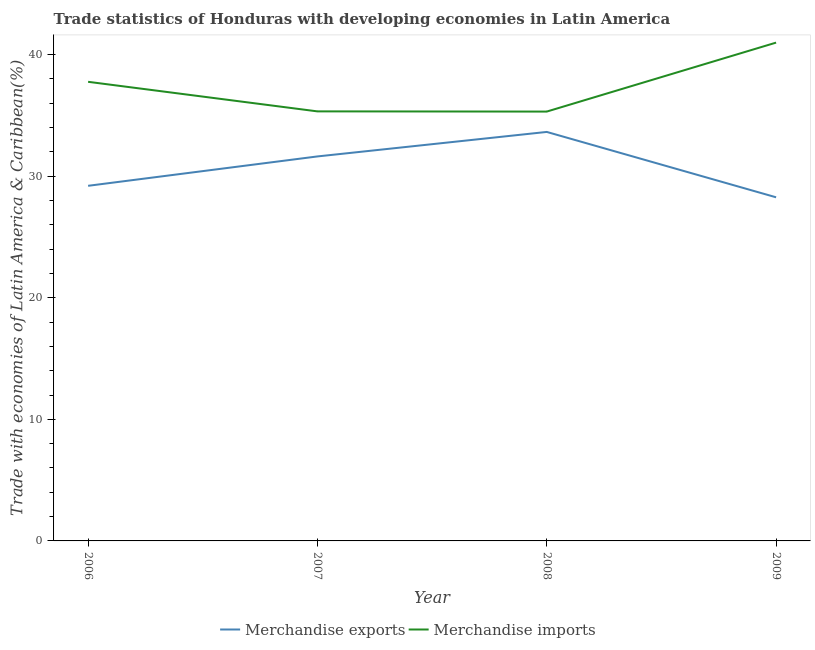What is the merchandise imports in 2009?
Your answer should be very brief. 40.98. Across all years, what is the maximum merchandise exports?
Your answer should be very brief. 33.63. Across all years, what is the minimum merchandise imports?
Give a very brief answer. 35.31. What is the total merchandise imports in the graph?
Provide a succinct answer. 149.37. What is the difference between the merchandise imports in 2006 and that in 2007?
Give a very brief answer. 2.43. What is the difference between the merchandise imports in 2007 and the merchandise exports in 2006?
Your answer should be compact. 6.12. What is the average merchandise exports per year?
Make the answer very short. 30.68. In the year 2007, what is the difference between the merchandise imports and merchandise exports?
Ensure brevity in your answer.  3.7. What is the ratio of the merchandise exports in 2006 to that in 2007?
Your response must be concise. 0.92. Is the difference between the merchandise exports in 2006 and 2009 greater than the difference between the merchandise imports in 2006 and 2009?
Your response must be concise. Yes. What is the difference between the highest and the second highest merchandise exports?
Offer a very short reply. 2.01. What is the difference between the highest and the lowest merchandise exports?
Offer a very short reply. 5.38. In how many years, is the merchandise imports greater than the average merchandise imports taken over all years?
Offer a terse response. 2. How many lines are there?
Provide a short and direct response. 2. How many years are there in the graph?
Keep it short and to the point. 4. What is the difference between two consecutive major ticks on the Y-axis?
Give a very brief answer. 10. Where does the legend appear in the graph?
Provide a succinct answer. Bottom center. How are the legend labels stacked?
Provide a short and direct response. Horizontal. What is the title of the graph?
Keep it short and to the point. Trade statistics of Honduras with developing economies in Latin America. Does "Diarrhea" appear as one of the legend labels in the graph?
Offer a very short reply. No. What is the label or title of the X-axis?
Make the answer very short. Year. What is the label or title of the Y-axis?
Keep it short and to the point. Trade with economies of Latin America & Caribbean(%). What is the Trade with economies of Latin America & Caribbean(%) in Merchandise exports in 2006?
Your response must be concise. 29.2. What is the Trade with economies of Latin America & Caribbean(%) in Merchandise imports in 2006?
Provide a succinct answer. 37.76. What is the Trade with economies of Latin America & Caribbean(%) of Merchandise exports in 2007?
Make the answer very short. 31.62. What is the Trade with economies of Latin America & Caribbean(%) of Merchandise imports in 2007?
Make the answer very short. 35.32. What is the Trade with economies of Latin America & Caribbean(%) of Merchandise exports in 2008?
Your answer should be compact. 33.63. What is the Trade with economies of Latin America & Caribbean(%) in Merchandise imports in 2008?
Your answer should be compact. 35.31. What is the Trade with economies of Latin America & Caribbean(%) of Merchandise exports in 2009?
Your answer should be very brief. 28.26. What is the Trade with economies of Latin America & Caribbean(%) of Merchandise imports in 2009?
Your answer should be compact. 40.98. Across all years, what is the maximum Trade with economies of Latin America & Caribbean(%) of Merchandise exports?
Provide a short and direct response. 33.63. Across all years, what is the maximum Trade with economies of Latin America & Caribbean(%) of Merchandise imports?
Make the answer very short. 40.98. Across all years, what is the minimum Trade with economies of Latin America & Caribbean(%) in Merchandise exports?
Make the answer very short. 28.26. Across all years, what is the minimum Trade with economies of Latin America & Caribbean(%) in Merchandise imports?
Give a very brief answer. 35.31. What is the total Trade with economies of Latin America & Caribbean(%) of Merchandise exports in the graph?
Your answer should be very brief. 122.71. What is the total Trade with economies of Latin America & Caribbean(%) of Merchandise imports in the graph?
Offer a very short reply. 149.37. What is the difference between the Trade with economies of Latin America & Caribbean(%) in Merchandise exports in 2006 and that in 2007?
Your answer should be very brief. -2.42. What is the difference between the Trade with economies of Latin America & Caribbean(%) in Merchandise imports in 2006 and that in 2007?
Keep it short and to the point. 2.43. What is the difference between the Trade with economies of Latin America & Caribbean(%) of Merchandise exports in 2006 and that in 2008?
Offer a terse response. -4.43. What is the difference between the Trade with economies of Latin America & Caribbean(%) in Merchandise imports in 2006 and that in 2008?
Offer a very short reply. 2.45. What is the difference between the Trade with economies of Latin America & Caribbean(%) in Merchandise exports in 2006 and that in 2009?
Provide a short and direct response. 0.95. What is the difference between the Trade with economies of Latin America & Caribbean(%) of Merchandise imports in 2006 and that in 2009?
Your answer should be compact. -3.22. What is the difference between the Trade with economies of Latin America & Caribbean(%) of Merchandise exports in 2007 and that in 2008?
Make the answer very short. -2.01. What is the difference between the Trade with economies of Latin America & Caribbean(%) of Merchandise imports in 2007 and that in 2008?
Make the answer very short. 0.02. What is the difference between the Trade with economies of Latin America & Caribbean(%) in Merchandise exports in 2007 and that in 2009?
Offer a very short reply. 3.36. What is the difference between the Trade with economies of Latin America & Caribbean(%) of Merchandise imports in 2007 and that in 2009?
Your response must be concise. -5.66. What is the difference between the Trade with economies of Latin America & Caribbean(%) in Merchandise exports in 2008 and that in 2009?
Provide a short and direct response. 5.38. What is the difference between the Trade with economies of Latin America & Caribbean(%) in Merchandise imports in 2008 and that in 2009?
Your answer should be compact. -5.67. What is the difference between the Trade with economies of Latin America & Caribbean(%) in Merchandise exports in 2006 and the Trade with economies of Latin America & Caribbean(%) in Merchandise imports in 2007?
Your answer should be compact. -6.12. What is the difference between the Trade with economies of Latin America & Caribbean(%) in Merchandise exports in 2006 and the Trade with economies of Latin America & Caribbean(%) in Merchandise imports in 2008?
Offer a very short reply. -6.11. What is the difference between the Trade with economies of Latin America & Caribbean(%) in Merchandise exports in 2006 and the Trade with economies of Latin America & Caribbean(%) in Merchandise imports in 2009?
Provide a succinct answer. -11.78. What is the difference between the Trade with economies of Latin America & Caribbean(%) of Merchandise exports in 2007 and the Trade with economies of Latin America & Caribbean(%) of Merchandise imports in 2008?
Your answer should be compact. -3.69. What is the difference between the Trade with economies of Latin America & Caribbean(%) in Merchandise exports in 2007 and the Trade with economies of Latin America & Caribbean(%) in Merchandise imports in 2009?
Offer a very short reply. -9.36. What is the difference between the Trade with economies of Latin America & Caribbean(%) of Merchandise exports in 2008 and the Trade with economies of Latin America & Caribbean(%) of Merchandise imports in 2009?
Your answer should be very brief. -7.35. What is the average Trade with economies of Latin America & Caribbean(%) in Merchandise exports per year?
Offer a very short reply. 30.68. What is the average Trade with economies of Latin America & Caribbean(%) in Merchandise imports per year?
Your answer should be very brief. 37.34. In the year 2006, what is the difference between the Trade with economies of Latin America & Caribbean(%) of Merchandise exports and Trade with economies of Latin America & Caribbean(%) of Merchandise imports?
Ensure brevity in your answer.  -8.55. In the year 2007, what is the difference between the Trade with economies of Latin America & Caribbean(%) of Merchandise exports and Trade with economies of Latin America & Caribbean(%) of Merchandise imports?
Make the answer very short. -3.7. In the year 2008, what is the difference between the Trade with economies of Latin America & Caribbean(%) of Merchandise exports and Trade with economies of Latin America & Caribbean(%) of Merchandise imports?
Make the answer very short. -1.67. In the year 2009, what is the difference between the Trade with economies of Latin America & Caribbean(%) of Merchandise exports and Trade with economies of Latin America & Caribbean(%) of Merchandise imports?
Make the answer very short. -12.72. What is the ratio of the Trade with economies of Latin America & Caribbean(%) in Merchandise exports in 2006 to that in 2007?
Give a very brief answer. 0.92. What is the ratio of the Trade with economies of Latin America & Caribbean(%) in Merchandise imports in 2006 to that in 2007?
Keep it short and to the point. 1.07. What is the ratio of the Trade with economies of Latin America & Caribbean(%) in Merchandise exports in 2006 to that in 2008?
Keep it short and to the point. 0.87. What is the ratio of the Trade with economies of Latin America & Caribbean(%) of Merchandise imports in 2006 to that in 2008?
Offer a terse response. 1.07. What is the ratio of the Trade with economies of Latin America & Caribbean(%) in Merchandise exports in 2006 to that in 2009?
Make the answer very short. 1.03. What is the ratio of the Trade with economies of Latin America & Caribbean(%) in Merchandise imports in 2006 to that in 2009?
Offer a very short reply. 0.92. What is the ratio of the Trade with economies of Latin America & Caribbean(%) in Merchandise exports in 2007 to that in 2008?
Your answer should be very brief. 0.94. What is the ratio of the Trade with economies of Latin America & Caribbean(%) of Merchandise imports in 2007 to that in 2008?
Give a very brief answer. 1. What is the ratio of the Trade with economies of Latin America & Caribbean(%) in Merchandise exports in 2007 to that in 2009?
Offer a very short reply. 1.12. What is the ratio of the Trade with economies of Latin America & Caribbean(%) of Merchandise imports in 2007 to that in 2009?
Make the answer very short. 0.86. What is the ratio of the Trade with economies of Latin America & Caribbean(%) of Merchandise exports in 2008 to that in 2009?
Provide a short and direct response. 1.19. What is the ratio of the Trade with economies of Latin America & Caribbean(%) in Merchandise imports in 2008 to that in 2009?
Your answer should be very brief. 0.86. What is the difference between the highest and the second highest Trade with economies of Latin America & Caribbean(%) in Merchandise exports?
Your response must be concise. 2.01. What is the difference between the highest and the second highest Trade with economies of Latin America & Caribbean(%) in Merchandise imports?
Keep it short and to the point. 3.22. What is the difference between the highest and the lowest Trade with economies of Latin America & Caribbean(%) in Merchandise exports?
Offer a very short reply. 5.38. What is the difference between the highest and the lowest Trade with economies of Latin America & Caribbean(%) in Merchandise imports?
Offer a very short reply. 5.67. 